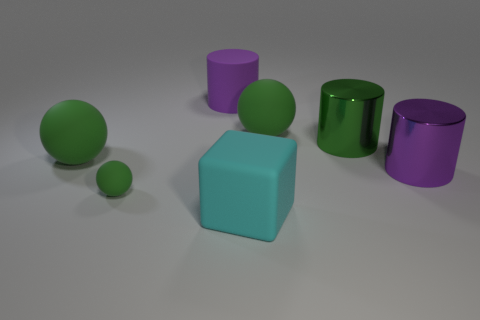How many green spheres must be subtracted to get 1 green spheres? 2 Add 6 green metallic objects. How many green metallic objects exist? 7 Add 3 big green things. How many objects exist? 10 Subtract all purple cylinders. How many cylinders are left? 1 Subtract all big green cylinders. How many cylinders are left? 2 Subtract 1 green cylinders. How many objects are left? 6 Subtract all cylinders. How many objects are left? 4 Subtract 1 spheres. How many spheres are left? 2 Subtract all blue spheres. Subtract all green cylinders. How many spheres are left? 3 Subtract all yellow spheres. How many green cylinders are left? 1 